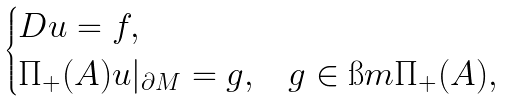Convert formula to latex. <formula><loc_0><loc_0><loc_500><loc_500>\begin{cases} D u = f , \\ \Pi _ { + } ( A ) u | _ { \partial M } = g , & g \in \i m \Pi _ { + } ( A ) , \end{cases}</formula> 